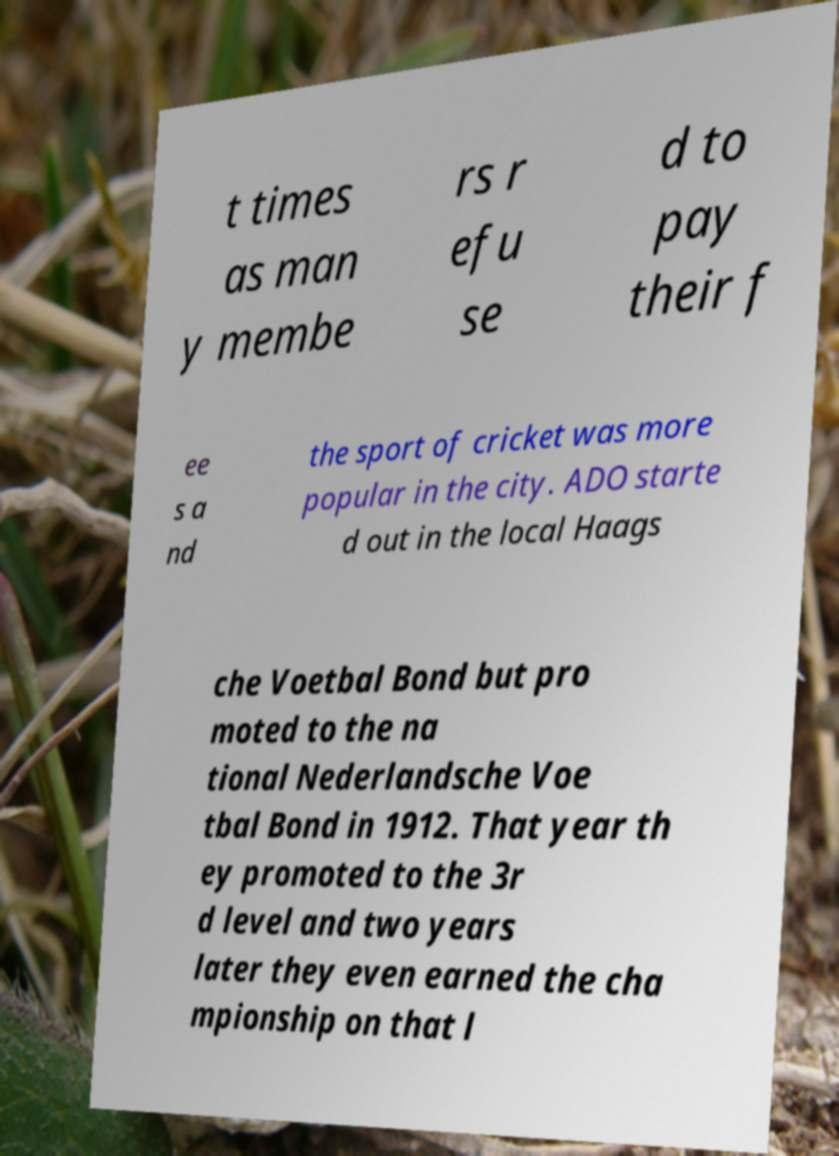What messages or text are displayed in this image? I need them in a readable, typed format. t times as man y membe rs r efu se d to pay their f ee s a nd the sport of cricket was more popular in the city. ADO starte d out in the local Haags che Voetbal Bond but pro moted to the na tional Nederlandsche Voe tbal Bond in 1912. That year th ey promoted to the 3r d level and two years later they even earned the cha mpionship on that l 